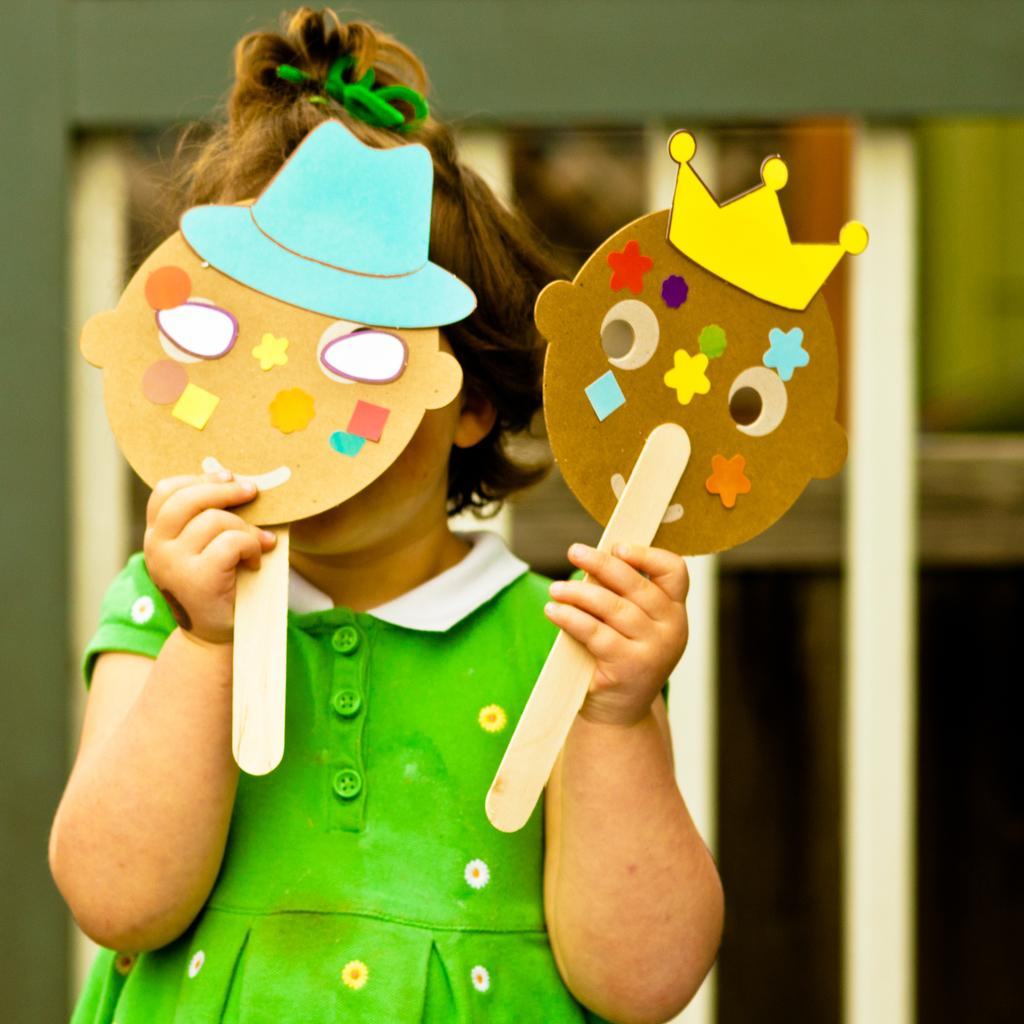What is the main subject of the image? There is a child in the image. What is the child holding in the image? The child is holding two boards in the image. Are there any decorations or designs on the boards? Yes, the boards have stickers pasted on them. What can be seen in the background of the image? There is a wall in the background of the image. What type of condition do the fairies in the image have? There are no fairies present in the image. What is the stage setup like in the image? There is no stage present in the image. 